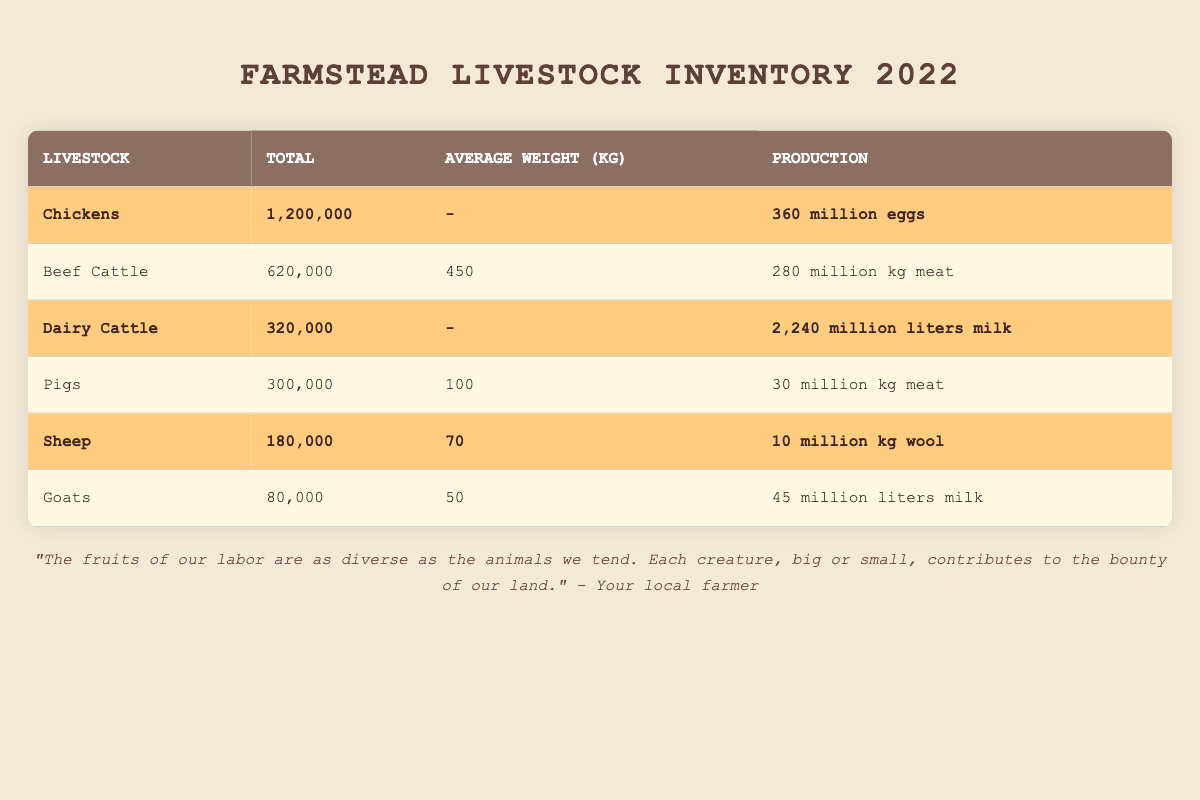What is the total number of chickens in the inventory? The table shows that the total number of chickens is listed clearly under the "Total" column for Chickens, which is 1,200,000.
Answer: 1,200,000 How much milk is produced by dairy cattle in million liters? The table directly indicates that dairy cattle produce 2,240 million liters of milk, which is stated under the "Production" column for Dairy Cattle.
Answer: 2,240 million liters Which livestock has the highest total number? By scanning the "Total" column, it's clear that Chickens have the highest total with 1,200,000, surpassing other livestock totals.
Answer: Chickens What is the average weight of pigs? The average weight of pigs is provided directly in the "Average Weight (kg)" column for Pigs, which states it is 100 kg.
Answer: 100 kg How much meat do beef cattle produce compared to pigs? Beef Cattle produce 280 million kg of meat, while Pigs produce 30 million kg. Subtracting these gives 280 - 30 = 250 million kg more meat produced by beef cattle.
Answer: 250 million kg Is the total wool production from sheep greater than meat production from pigs? The total wool production from Sheep is 10 million kg, and total meat production from Pigs is 30 million kg. Since 10 is less than 30, the statement is false.
Answer: No What are the combined total livestock of meat-producing animals (Beef Cattle, Pigs, and Sheep)? We sum the totals for Beef Cattle (620,000), Pigs (300,000), and Sheep (180,000): 620,000 + 300,000 + 180,000 = 1,100,000.
Answer: 1,100,000 What type of livestock has the lowest total number in the inventory? Looking through the "Total" column, we see Goats with a tally of 80,000, which is less than any other livestock.
Answer: Goats If you combine total milk production from dairy cattle and goats, how much would that be? Dairy Cattle produce 2,240 million liters of milk and Goats produce 45 million liters. Combined, this is 2,240 + 45 = 2,285 million liters.
Answer: 2,285 million liters Which type of livestock contributes to the most wool production? The table highlights that Sheep have a total wool production of 10 million kg, which is listed under their section and is the highest among all livestock.
Answer: Sheep 